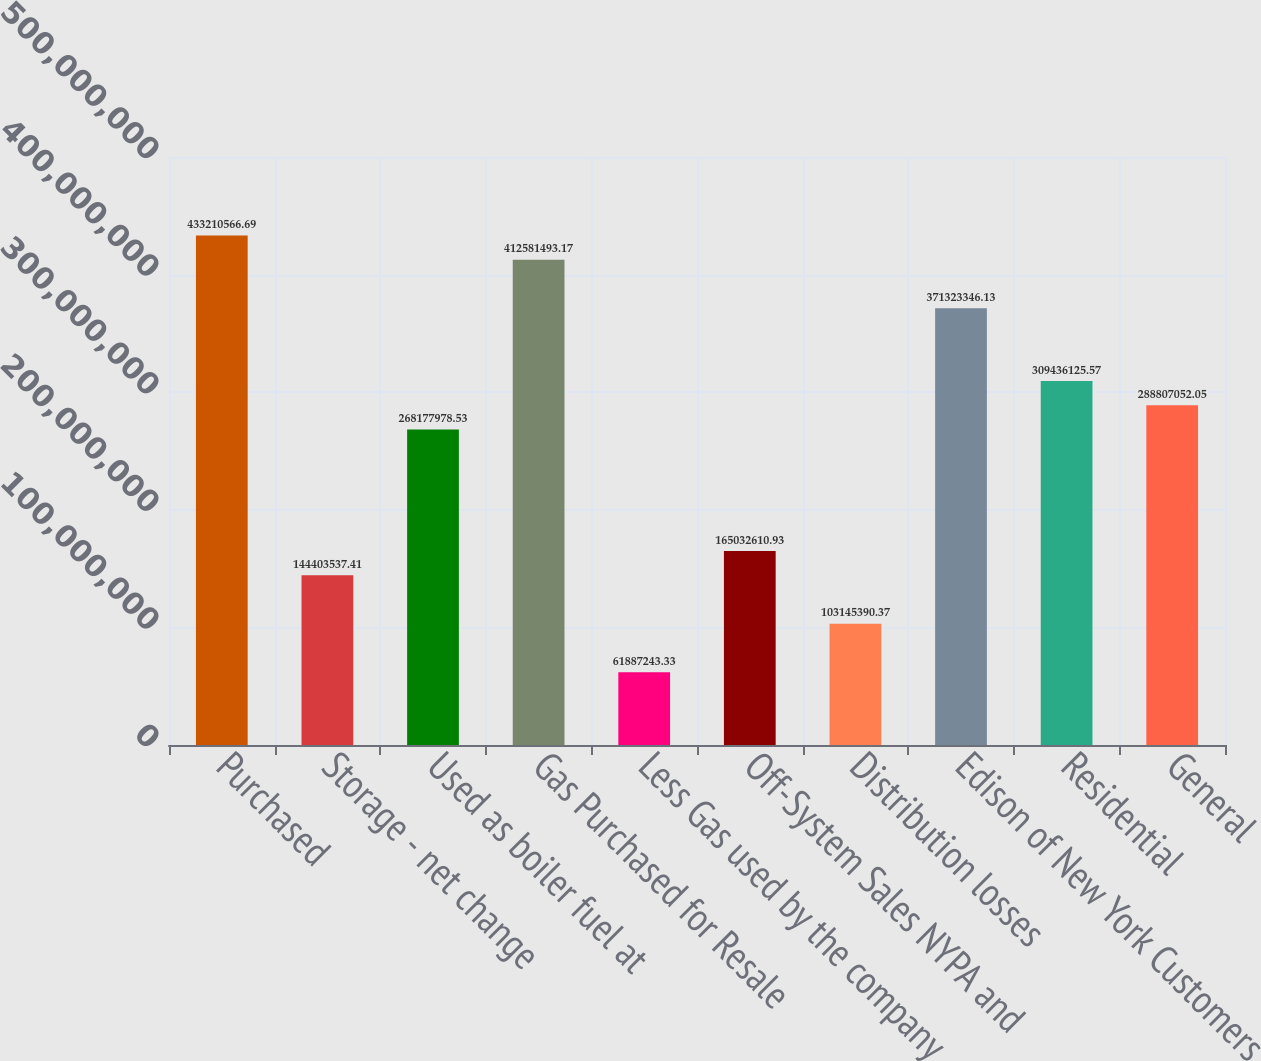Convert chart. <chart><loc_0><loc_0><loc_500><loc_500><bar_chart><fcel>Purchased<fcel>Storage - net change<fcel>Used as boiler fuel at<fcel>Gas Purchased for Resale<fcel>Less Gas used by the company<fcel>Off-System Sales NYPA and<fcel>Distribution losses<fcel>Edison of New York Customers<fcel>Residential<fcel>General<nl><fcel>4.33211e+08<fcel>1.44404e+08<fcel>2.68178e+08<fcel>4.12581e+08<fcel>6.18872e+07<fcel>1.65033e+08<fcel>1.03145e+08<fcel>3.71323e+08<fcel>3.09436e+08<fcel>2.88807e+08<nl></chart> 